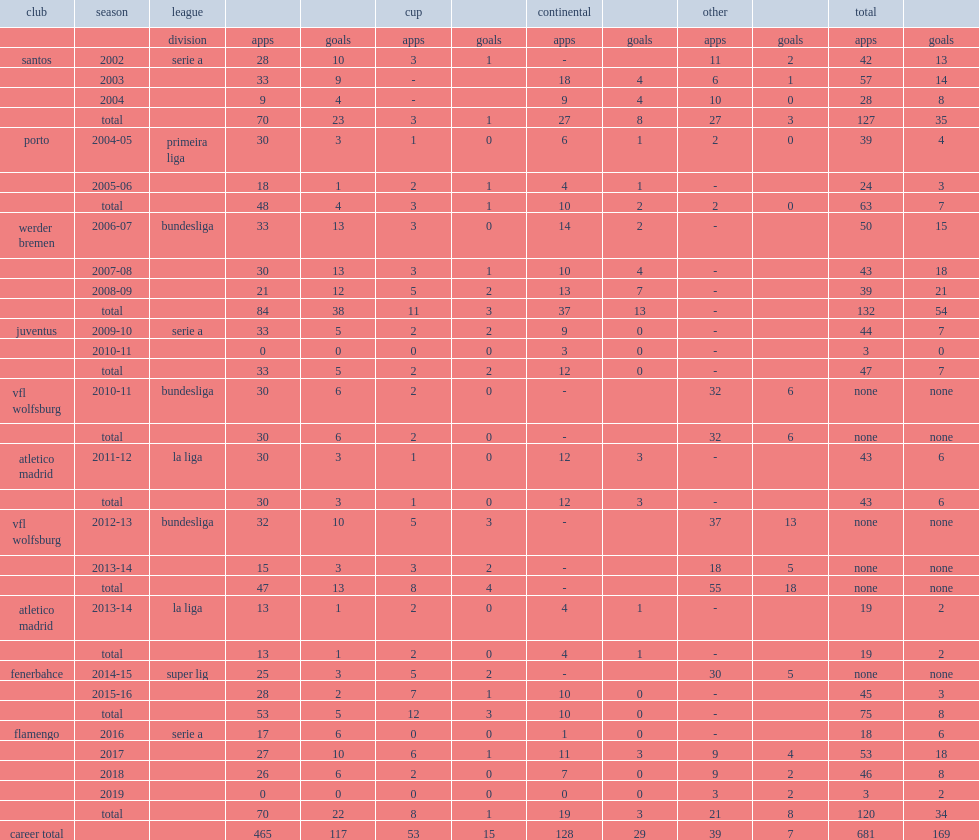Which club did diego begin his career with before moving to porto in 2004? Santos. 